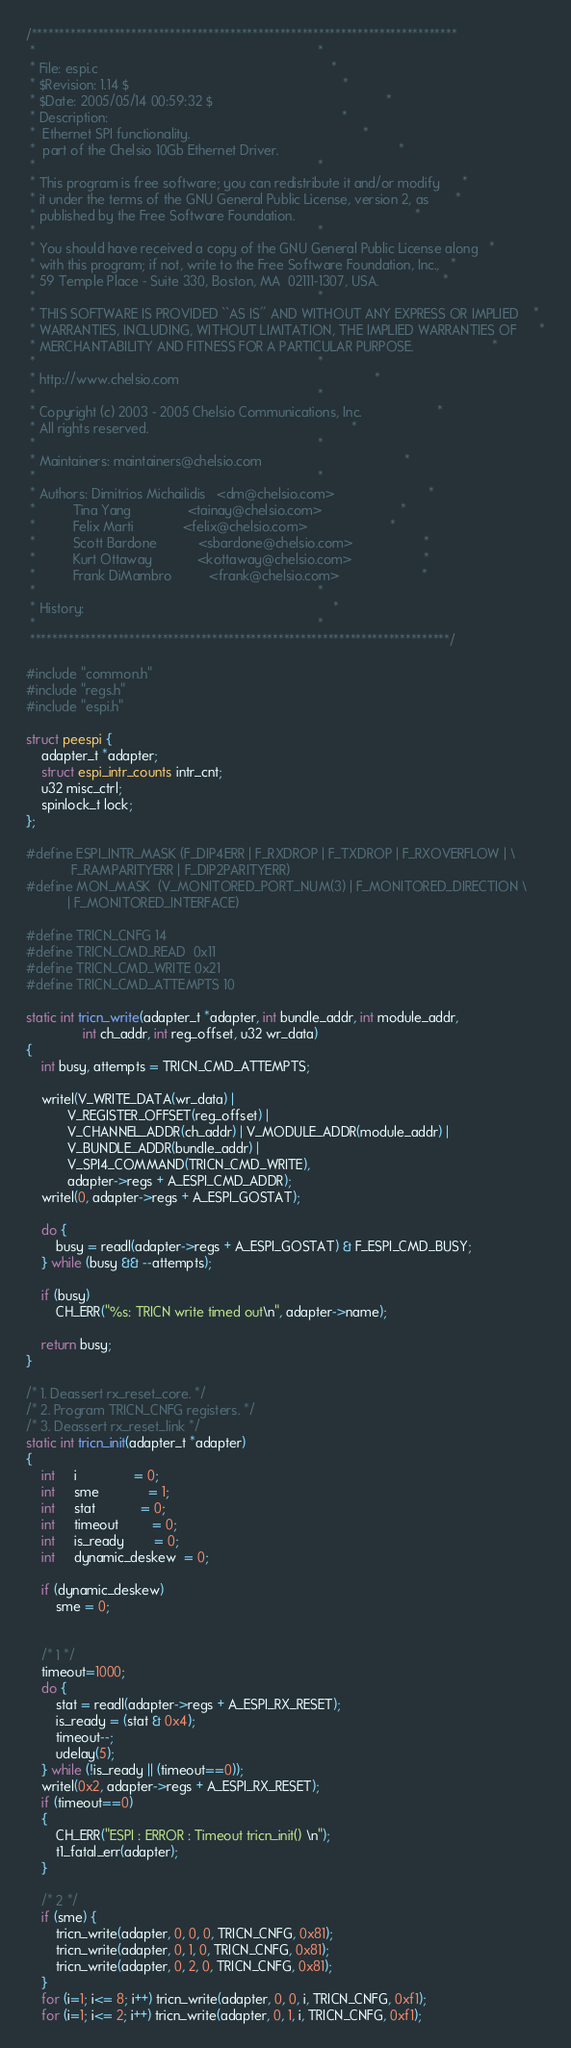<code> <loc_0><loc_0><loc_500><loc_500><_C_>/*****************************************************************************
 *                                                                           *
 * File: espi.c                                                              *
 * $Revision: 1.14 $                                                         *
 * $Date: 2005/05/14 00:59:32 $                                              *
 * Description:                                                              *
 *  Ethernet SPI functionality.                                              *
 *  part of the Chelsio 10Gb Ethernet Driver.                                *
 *                                                                           *
 * This program is free software; you can redistribute it and/or modify      *
 * it under the terms of the GNU General Public License, version 2, as       *
 * published by the Free Software Foundation.                                *
 *                                                                           *
 * You should have received a copy of the GNU General Public License along   *
 * with this program; if not, write to the Free Software Foundation, Inc.,   *
 * 59 Temple Place - Suite 330, Boston, MA  02111-1307, USA.                 *
 *                                                                           *
 * THIS SOFTWARE IS PROVIDED ``AS IS'' AND WITHOUT ANY EXPRESS OR IMPLIED    *
 * WARRANTIES, INCLUDING, WITHOUT LIMITATION, THE IMPLIED WARRANTIES OF      *
 * MERCHANTABILITY AND FITNESS FOR A PARTICULAR PURPOSE.                     *
 *                                                                           *
 * http://www.chelsio.com                                                    *
 *                                                                           *
 * Copyright (c) 2003 - 2005 Chelsio Communications, Inc.                    *
 * All rights reserved.                                                      *
 *                                                                           *
 * Maintainers: maintainers@chelsio.com                                      *
 *                                                                           *
 * Authors: Dimitrios Michailidis   <dm@chelsio.com>                         *
 *          Tina Yang               <tainay@chelsio.com>                     *
 *          Felix Marti             <felix@chelsio.com>                      *
 *          Scott Bardone           <sbardone@chelsio.com>                   *
 *          Kurt Ottaway            <kottaway@chelsio.com>                   *
 *          Frank DiMambro          <frank@chelsio.com>                      *
 *                                                                           *
 * History:                                                                  *
 *                                                                           *
 ****************************************************************************/

#include "common.h"
#include "regs.h"
#include "espi.h"

struct peespi {
	adapter_t *adapter;
	struct espi_intr_counts intr_cnt;
	u32 misc_ctrl;
	spinlock_t lock;
};

#define ESPI_INTR_MASK (F_DIP4ERR | F_RXDROP | F_TXDROP | F_RXOVERFLOW | \
			F_RAMPARITYERR | F_DIP2PARITYERR)
#define MON_MASK  (V_MONITORED_PORT_NUM(3) | F_MONITORED_DIRECTION \
		   | F_MONITORED_INTERFACE)

#define TRICN_CNFG 14
#define TRICN_CMD_READ  0x11
#define TRICN_CMD_WRITE 0x21
#define TRICN_CMD_ATTEMPTS 10

static int tricn_write(adapter_t *adapter, int bundle_addr, int module_addr,
		       int ch_addr, int reg_offset, u32 wr_data)
{
	int busy, attempts = TRICN_CMD_ATTEMPTS;

	writel(V_WRITE_DATA(wr_data) |
	       V_REGISTER_OFFSET(reg_offset) |
	       V_CHANNEL_ADDR(ch_addr) | V_MODULE_ADDR(module_addr) |
	       V_BUNDLE_ADDR(bundle_addr) |
	       V_SPI4_COMMAND(TRICN_CMD_WRITE),
	       adapter->regs + A_ESPI_CMD_ADDR);
	writel(0, adapter->regs + A_ESPI_GOSTAT);

	do {
		busy = readl(adapter->regs + A_ESPI_GOSTAT) & F_ESPI_CMD_BUSY;
	} while (busy && --attempts);

	if (busy)
		CH_ERR("%s: TRICN write timed out\n", adapter->name);

	return busy;
}

/* 1. Deassert rx_reset_core. */
/* 2. Program TRICN_CNFG registers. */
/* 3. Deassert rx_reset_link */
static int tricn_init(adapter_t *adapter)
{
	int     i               = 0;
	int     sme             = 1;
	int     stat            = 0;
	int     timeout         = 0;
	int     is_ready        = 0;
	int     dynamic_deskew  = 0;

	if (dynamic_deskew)
		sme = 0;


	/* 1 */
	timeout=1000;
	do {
		stat = readl(adapter->regs + A_ESPI_RX_RESET);
		is_ready = (stat & 0x4);
		timeout--;
		udelay(5);
	} while (!is_ready || (timeout==0));
	writel(0x2, adapter->regs + A_ESPI_RX_RESET);
	if (timeout==0)
	{
		CH_ERR("ESPI : ERROR : Timeout tricn_init() \n");
		t1_fatal_err(adapter);
	}

	/* 2 */
	if (sme) {
		tricn_write(adapter, 0, 0, 0, TRICN_CNFG, 0x81);
		tricn_write(adapter, 0, 1, 0, TRICN_CNFG, 0x81);
		tricn_write(adapter, 0, 2, 0, TRICN_CNFG, 0x81);
	}
	for (i=1; i<= 8; i++) tricn_write(adapter, 0, 0, i, TRICN_CNFG, 0xf1);
	for (i=1; i<= 2; i++) tricn_write(adapter, 0, 1, i, TRICN_CNFG, 0xf1);</code> 